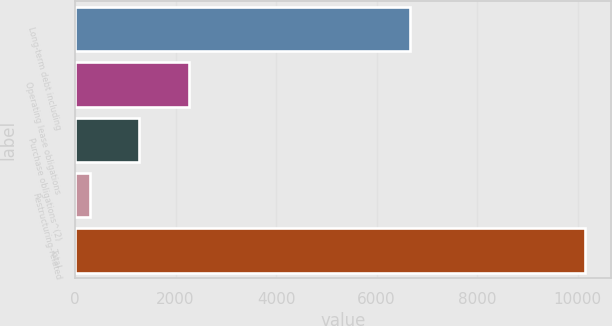Convert chart. <chart><loc_0><loc_0><loc_500><loc_500><bar_chart><fcel>Long-term debt including<fcel>Operating lease obligations<fcel>Purchase obligations^(2)<fcel>Restructuring-related<fcel>Total<nl><fcel>6668<fcel>2265.2<fcel>1279.6<fcel>294<fcel>10150<nl></chart> 